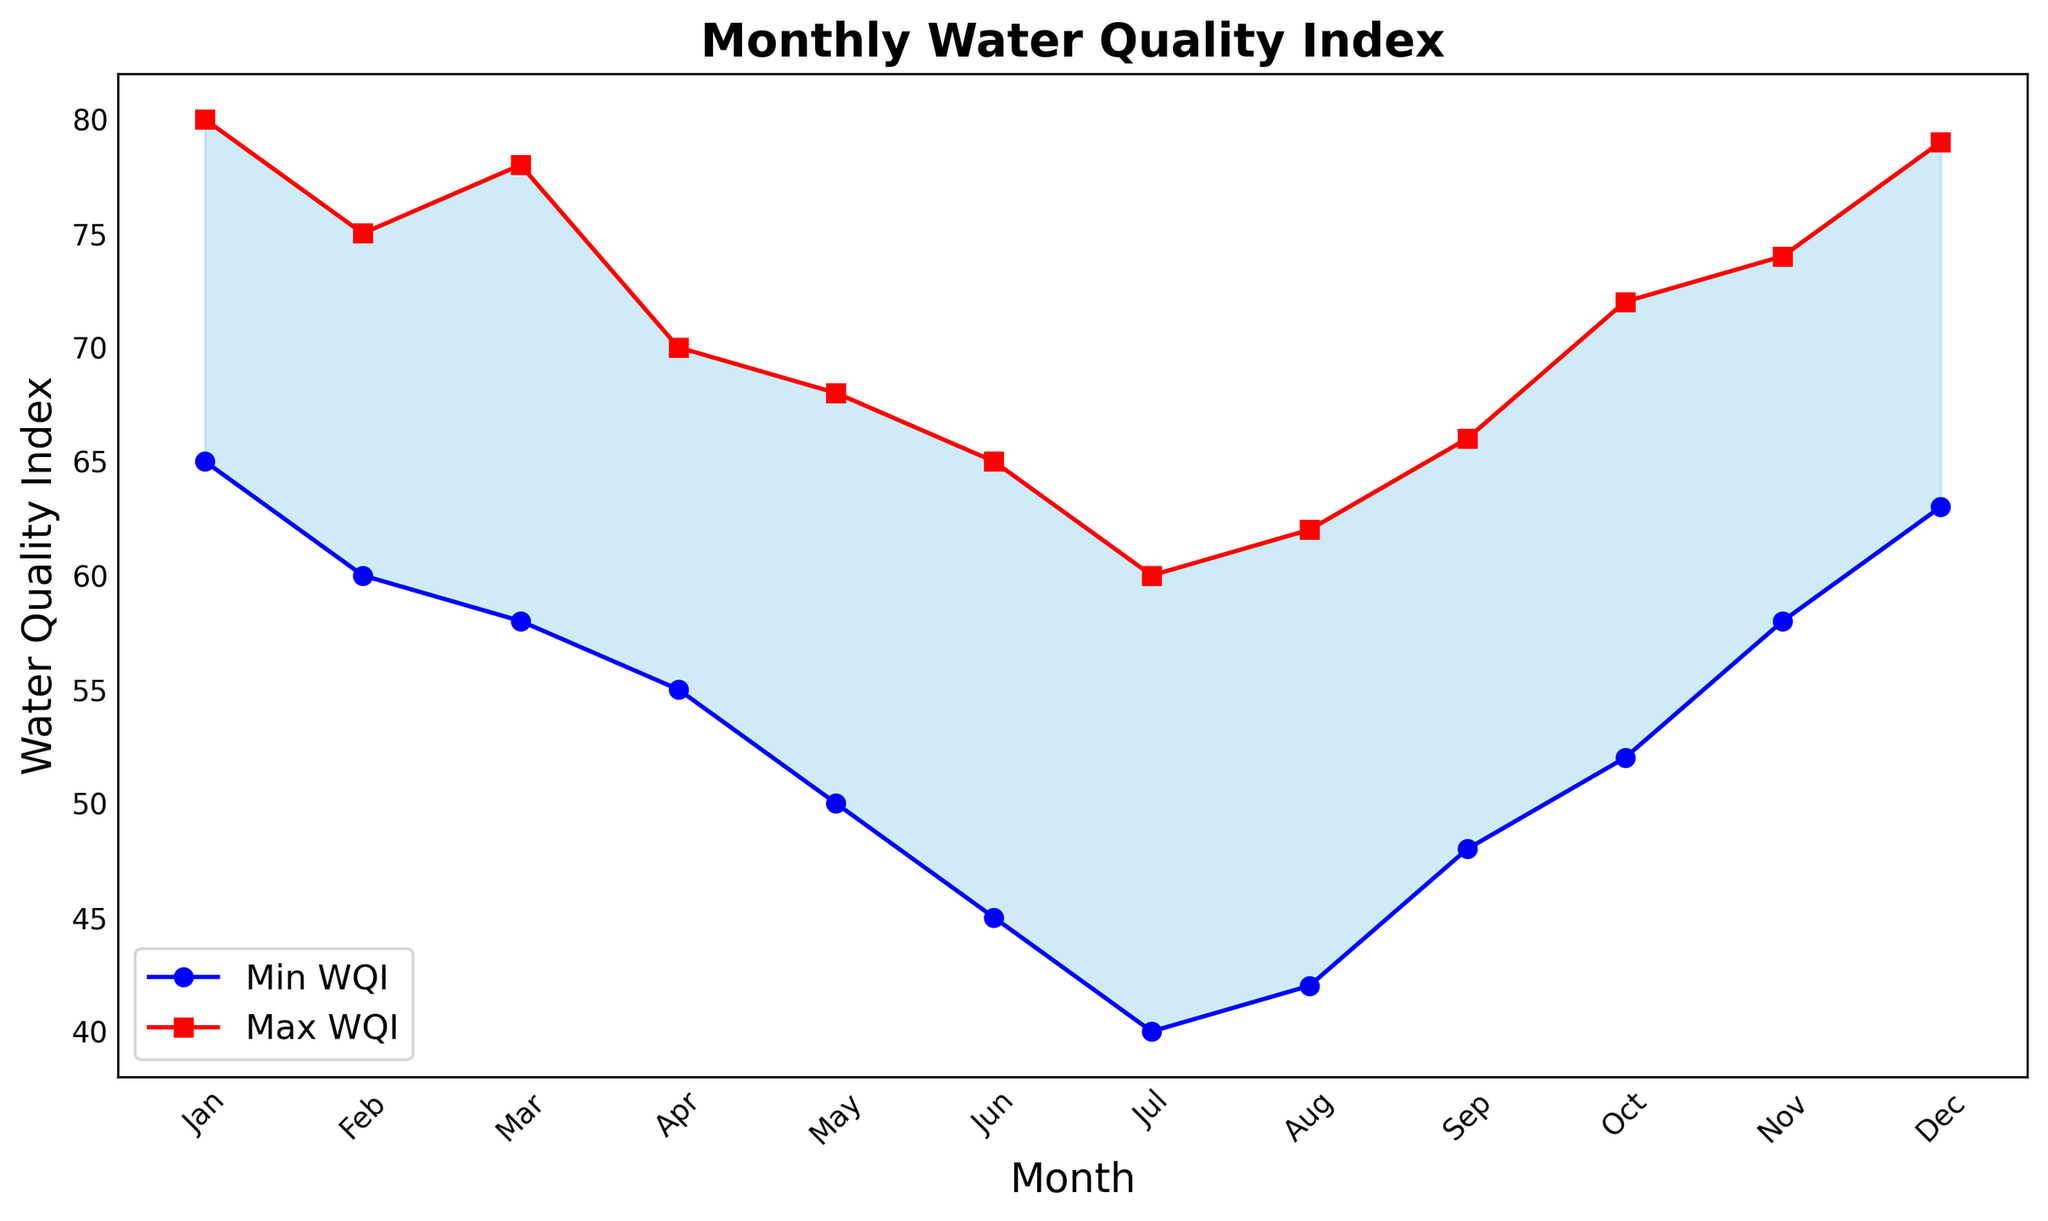What's the range of the Water Quality Index (WQI) in July? In July, the minimum WQI is 40 and the maximum WQI is 60, so the range is 60 - 40 = 20
Answer: 20 During which month is the difference between the maximum and minimum WQI the smallest? To find the month with the smallest difference between the maximum and minimum WQI, we need to look at the difference column for each month. August shows the smallest difference with max WQI 62 and min WQI 42, making it 62 - 42 = 20
Answer: August How does the Water Quality Index trend visually from January to December? Observing the figure, we can see that both the maximum (red line) and minimum (blue line) WQI values generally decrease from January to July, reaching the lowest point in July, and then increasing again towards December
Answer: Decreases then increases Which month shows the highest maximum Water Quality Index? By looking at the red line, we can see that the highest maximum WQI occurs in January as the red line peaks at the y-value of 80
Answer: January Compare the Water Quality Index in May and October. Which month has a higher range? For May, the max WQI is 68 and min WQI is 50, giving a range of 68 - 50 = 18. For October, the max WQI is 72 and min WQI is 52, giving a range of 72 - 52 = 20. Therefore, October has a higher range
Answer: October From the figure, identify the months where the minimum WQI is equal to or greater than 50. The blue line (minimum WQI) is at or above the y-value of 50 in the months: Jan, Feb, Mar, Apr, May, Oct, Nov, Dec
Answer: Jan, Feb, Mar, Apr, May, Oct, Nov, Dec In which month is the average WQI the lowest? To find this, calculate the average WQI for each month: (Min WQI + Max WQI) / 2 for each month. The averages are: Jan:72.5, Feb:67.5, Mar:68, Apr:62.5, May:59, Jun:55, Jul:50, Aug:52, Sep:57, Oct:62, Nov:66, Dec:71. The lowest average is in July
Answer: July In which months does the minimum Water Quality Index fall below 50? Observing the blue line, it dips below the y-value of 50 in June, July, and August
Answer: June, July, August 